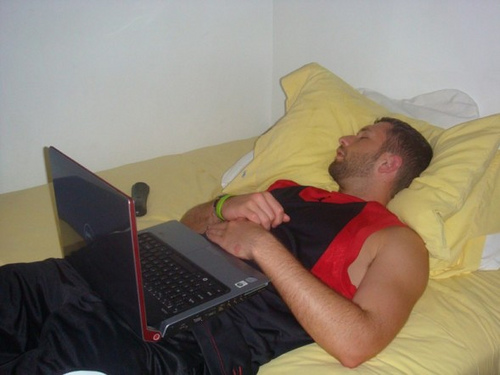What can you infer about the person in the image? The individual in the image appears to be a young adult who is resting or asleep on a bed. The presence of a laptop on his lap suggests he might have been working, studying, or watching something before falling asleep. His casual attire, a sleeveless black and red sports jersey, and matching shorts, imply a relaxed or informal setting, possibly at home. The remote control nearby indicates he might occasionally watch television or use it for other electronic devices. The overall scene suggests a moment of downtime or rest during a busy day. 